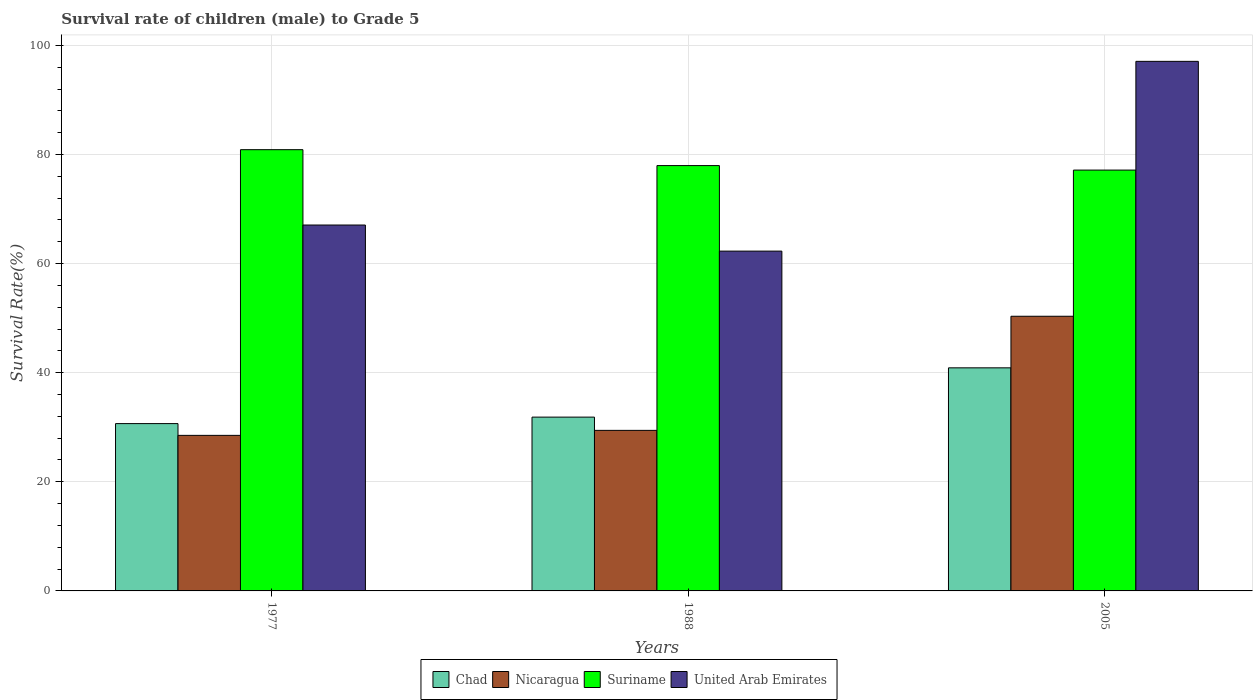How many groups of bars are there?
Provide a succinct answer. 3. Are the number of bars on each tick of the X-axis equal?
Provide a short and direct response. Yes. What is the label of the 2nd group of bars from the left?
Keep it short and to the point. 1988. What is the survival rate of male children to grade 5 in Suriname in 2005?
Make the answer very short. 77.14. Across all years, what is the maximum survival rate of male children to grade 5 in Nicaragua?
Offer a very short reply. 50.35. Across all years, what is the minimum survival rate of male children to grade 5 in United Arab Emirates?
Offer a very short reply. 62.29. In which year was the survival rate of male children to grade 5 in Chad minimum?
Keep it short and to the point. 1977. What is the total survival rate of male children to grade 5 in Suriname in the graph?
Your response must be concise. 235.98. What is the difference between the survival rate of male children to grade 5 in Nicaragua in 1977 and that in 1988?
Your answer should be very brief. -0.92. What is the difference between the survival rate of male children to grade 5 in United Arab Emirates in 1988 and the survival rate of male children to grade 5 in Suriname in 2005?
Offer a very short reply. -14.85. What is the average survival rate of male children to grade 5 in United Arab Emirates per year?
Make the answer very short. 75.47. In the year 2005, what is the difference between the survival rate of male children to grade 5 in Suriname and survival rate of male children to grade 5 in Chad?
Offer a terse response. 36.25. What is the ratio of the survival rate of male children to grade 5 in Nicaragua in 1977 to that in 1988?
Keep it short and to the point. 0.97. Is the survival rate of male children to grade 5 in United Arab Emirates in 1988 less than that in 2005?
Provide a succinct answer. Yes. What is the difference between the highest and the second highest survival rate of male children to grade 5 in United Arab Emirates?
Your answer should be very brief. 30. What is the difference between the highest and the lowest survival rate of male children to grade 5 in Nicaragua?
Offer a terse response. 21.83. What does the 3rd bar from the left in 1977 represents?
Your answer should be compact. Suriname. What does the 4th bar from the right in 1988 represents?
Provide a succinct answer. Chad. How many bars are there?
Your response must be concise. 12. Are all the bars in the graph horizontal?
Make the answer very short. No. How many years are there in the graph?
Your response must be concise. 3. What is the difference between two consecutive major ticks on the Y-axis?
Make the answer very short. 20. Are the values on the major ticks of Y-axis written in scientific E-notation?
Keep it short and to the point. No. Does the graph contain any zero values?
Your answer should be very brief. No. Does the graph contain grids?
Give a very brief answer. Yes. Where does the legend appear in the graph?
Your response must be concise. Bottom center. How many legend labels are there?
Your response must be concise. 4. What is the title of the graph?
Your response must be concise. Survival rate of children (male) to Grade 5. What is the label or title of the X-axis?
Give a very brief answer. Years. What is the label or title of the Y-axis?
Ensure brevity in your answer.  Survival Rate(%). What is the Survival Rate(%) in Chad in 1977?
Make the answer very short. 30.67. What is the Survival Rate(%) in Nicaragua in 1977?
Ensure brevity in your answer.  28.51. What is the Survival Rate(%) in Suriname in 1977?
Offer a very short reply. 80.88. What is the Survival Rate(%) of United Arab Emirates in 1977?
Your answer should be compact. 67.07. What is the Survival Rate(%) in Chad in 1988?
Your response must be concise. 31.86. What is the Survival Rate(%) in Nicaragua in 1988?
Keep it short and to the point. 29.43. What is the Survival Rate(%) in Suriname in 1988?
Make the answer very short. 77.97. What is the Survival Rate(%) in United Arab Emirates in 1988?
Offer a very short reply. 62.29. What is the Survival Rate(%) of Chad in 2005?
Your answer should be compact. 40.89. What is the Survival Rate(%) in Nicaragua in 2005?
Your answer should be very brief. 50.35. What is the Survival Rate(%) of Suriname in 2005?
Offer a very short reply. 77.14. What is the Survival Rate(%) of United Arab Emirates in 2005?
Provide a succinct answer. 97.07. Across all years, what is the maximum Survival Rate(%) of Chad?
Keep it short and to the point. 40.89. Across all years, what is the maximum Survival Rate(%) in Nicaragua?
Your answer should be very brief. 50.35. Across all years, what is the maximum Survival Rate(%) of Suriname?
Your response must be concise. 80.88. Across all years, what is the maximum Survival Rate(%) in United Arab Emirates?
Ensure brevity in your answer.  97.07. Across all years, what is the minimum Survival Rate(%) in Chad?
Give a very brief answer. 30.67. Across all years, what is the minimum Survival Rate(%) in Nicaragua?
Keep it short and to the point. 28.51. Across all years, what is the minimum Survival Rate(%) in Suriname?
Offer a terse response. 77.14. Across all years, what is the minimum Survival Rate(%) of United Arab Emirates?
Your answer should be compact. 62.29. What is the total Survival Rate(%) of Chad in the graph?
Make the answer very short. 103.42. What is the total Survival Rate(%) of Nicaragua in the graph?
Offer a terse response. 108.29. What is the total Survival Rate(%) in Suriname in the graph?
Make the answer very short. 235.98. What is the total Survival Rate(%) of United Arab Emirates in the graph?
Make the answer very short. 226.42. What is the difference between the Survival Rate(%) in Chad in 1977 and that in 1988?
Offer a very short reply. -1.19. What is the difference between the Survival Rate(%) in Nicaragua in 1977 and that in 1988?
Provide a succinct answer. -0.92. What is the difference between the Survival Rate(%) in Suriname in 1977 and that in 1988?
Your answer should be compact. 2.92. What is the difference between the Survival Rate(%) in United Arab Emirates in 1977 and that in 1988?
Ensure brevity in your answer.  4.78. What is the difference between the Survival Rate(%) in Chad in 1977 and that in 2005?
Provide a short and direct response. -10.22. What is the difference between the Survival Rate(%) of Nicaragua in 1977 and that in 2005?
Your response must be concise. -21.83. What is the difference between the Survival Rate(%) in Suriname in 1977 and that in 2005?
Make the answer very short. 3.74. What is the difference between the Survival Rate(%) of United Arab Emirates in 1977 and that in 2005?
Make the answer very short. -30. What is the difference between the Survival Rate(%) in Chad in 1988 and that in 2005?
Keep it short and to the point. -9.03. What is the difference between the Survival Rate(%) of Nicaragua in 1988 and that in 2005?
Your answer should be compact. -20.92. What is the difference between the Survival Rate(%) in Suriname in 1988 and that in 2005?
Offer a terse response. 0.83. What is the difference between the Survival Rate(%) in United Arab Emirates in 1988 and that in 2005?
Make the answer very short. -34.78. What is the difference between the Survival Rate(%) of Chad in 1977 and the Survival Rate(%) of Nicaragua in 1988?
Your answer should be very brief. 1.24. What is the difference between the Survival Rate(%) of Chad in 1977 and the Survival Rate(%) of Suriname in 1988?
Ensure brevity in your answer.  -47.29. What is the difference between the Survival Rate(%) of Chad in 1977 and the Survival Rate(%) of United Arab Emirates in 1988?
Make the answer very short. -31.62. What is the difference between the Survival Rate(%) of Nicaragua in 1977 and the Survival Rate(%) of Suriname in 1988?
Provide a succinct answer. -49.45. What is the difference between the Survival Rate(%) of Nicaragua in 1977 and the Survival Rate(%) of United Arab Emirates in 1988?
Offer a very short reply. -33.77. What is the difference between the Survival Rate(%) in Suriname in 1977 and the Survival Rate(%) in United Arab Emirates in 1988?
Ensure brevity in your answer.  18.59. What is the difference between the Survival Rate(%) in Chad in 1977 and the Survival Rate(%) in Nicaragua in 2005?
Provide a succinct answer. -19.68. What is the difference between the Survival Rate(%) of Chad in 1977 and the Survival Rate(%) of Suriname in 2005?
Make the answer very short. -46.47. What is the difference between the Survival Rate(%) of Chad in 1977 and the Survival Rate(%) of United Arab Emirates in 2005?
Your answer should be very brief. -66.4. What is the difference between the Survival Rate(%) of Nicaragua in 1977 and the Survival Rate(%) of Suriname in 2005?
Give a very brief answer. -48.63. What is the difference between the Survival Rate(%) of Nicaragua in 1977 and the Survival Rate(%) of United Arab Emirates in 2005?
Offer a very short reply. -68.56. What is the difference between the Survival Rate(%) in Suriname in 1977 and the Survival Rate(%) in United Arab Emirates in 2005?
Your response must be concise. -16.19. What is the difference between the Survival Rate(%) in Chad in 1988 and the Survival Rate(%) in Nicaragua in 2005?
Provide a succinct answer. -18.49. What is the difference between the Survival Rate(%) in Chad in 1988 and the Survival Rate(%) in Suriname in 2005?
Offer a terse response. -45.28. What is the difference between the Survival Rate(%) of Chad in 1988 and the Survival Rate(%) of United Arab Emirates in 2005?
Provide a succinct answer. -65.21. What is the difference between the Survival Rate(%) of Nicaragua in 1988 and the Survival Rate(%) of Suriname in 2005?
Ensure brevity in your answer.  -47.71. What is the difference between the Survival Rate(%) in Nicaragua in 1988 and the Survival Rate(%) in United Arab Emirates in 2005?
Provide a short and direct response. -67.64. What is the difference between the Survival Rate(%) of Suriname in 1988 and the Survival Rate(%) of United Arab Emirates in 2005?
Your answer should be compact. -19.1. What is the average Survival Rate(%) of Chad per year?
Your answer should be compact. 34.47. What is the average Survival Rate(%) in Nicaragua per year?
Your answer should be compact. 36.1. What is the average Survival Rate(%) in Suriname per year?
Your response must be concise. 78.66. What is the average Survival Rate(%) of United Arab Emirates per year?
Offer a very short reply. 75.47. In the year 1977, what is the difference between the Survival Rate(%) of Chad and Survival Rate(%) of Nicaragua?
Offer a terse response. 2.16. In the year 1977, what is the difference between the Survival Rate(%) in Chad and Survival Rate(%) in Suriname?
Keep it short and to the point. -50.21. In the year 1977, what is the difference between the Survival Rate(%) of Chad and Survival Rate(%) of United Arab Emirates?
Offer a very short reply. -36.4. In the year 1977, what is the difference between the Survival Rate(%) in Nicaragua and Survival Rate(%) in Suriname?
Your answer should be very brief. -52.37. In the year 1977, what is the difference between the Survival Rate(%) in Nicaragua and Survival Rate(%) in United Arab Emirates?
Keep it short and to the point. -38.56. In the year 1977, what is the difference between the Survival Rate(%) in Suriname and Survival Rate(%) in United Arab Emirates?
Provide a succinct answer. 13.81. In the year 1988, what is the difference between the Survival Rate(%) of Chad and Survival Rate(%) of Nicaragua?
Keep it short and to the point. 2.43. In the year 1988, what is the difference between the Survival Rate(%) of Chad and Survival Rate(%) of Suriname?
Make the answer very short. -46.11. In the year 1988, what is the difference between the Survival Rate(%) of Chad and Survival Rate(%) of United Arab Emirates?
Your answer should be very brief. -30.43. In the year 1988, what is the difference between the Survival Rate(%) of Nicaragua and Survival Rate(%) of Suriname?
Your answer should be very brief. -48.54. In the year 1988, what is the difference between the Survival Rate(%) in Nicaragua and Survival Rate(%) in United Arab Emirates?
Keep it short and to the point. -32.86. In the year 1988, what is the difference between the Survival Rate(%) of Suriname and Survival Rate(%) of United Arab Emirates?
Your answer should be compact. 15.68. In the year 2005, what is the difference between the Survival Rate(%) in Chad and Survival Rate(%) in Nicaragua?
Offer a very short reply. -9.46. In the year 2005, what is the difference between the Survival Rate(%) of Chad and Survival Rate(%) of Suriname?
Keep it short and to the point. -36.25. In the year 2005, what is the difference between the Survival Rate(%) in Chad and Survival Rate(%) in United Arab Emirates?
Your answer should be compact. -56.18. In the year 2005, what is the difference between the Survival Rate(%) of Nicaragua and Survival Rate(%) of Suriname?
Ensure brevity in your answer.  -26.79. In the year 2005, what is the difference between the Survival Rate(%) of Nicaragua and Survival Rate(%) of United Arab Emirates?
Offer a very short reply. -46.72. In the year 2005, what is the difference between the Survival Rate(%) in Suriname and Survival Rate(%) in United Arab Emirates?
Give a very brief answer. -19.93. What is the ratio of the Survival Rate(%) of Chad in 1977 to that in 1988?
Your answer should be very brief. 0.96. What is the ratio of the Survival Rate(%) in Nicaragua in 1977 to that in 1988?
Your answer should be very brief. 0.97. What is the ratio of the Survival Rate(%) in Suriname in 1977 to that in 1988?
Keep it short and to the point. 1.04. What is the ratio of the Survival Rate(%) of United Arab Emirates in 1977 to that in 1988?
Your answer should be very brief. 1.08. What is the ratio of the Survival Rate(%) in Chad in 1977 to that in 2005?
Ensure brevity in your answer.  0.75. What is the ratio of the Survival Rate(%) in Nicaragua in 1977 to that in 2005?
Make the answer very short. 0.57. What is the ratio of the Survival Rate(%) of Suriname in 1977 to that in 2005?
Provide a succinct answer. 1.05. What is the ratio of the Survival Rate(%) of United Arab Emirates in 1977 to that in 2005?
Your answer should be compact. 0.69. What is the ratio of the Survival Rate(%) in Chad in 1988 to that in 2005?
Ensure brevity in your answer.  0.78. What is the ratio of the Survival Rate(%) in Nicaragua in 1988 to that in 2005?
Offer a very short reply. 0.58. What is the ratio of the Survival Rate(%) in Suriname in 1988 to that in 2005?
Provide a short and direct response. 1.01. What is the ratio of the Survival Rate(%) in United Arab Emirates in 1988 to that in 2005?
Offer a very short reply. 0.64. What is the difference between the highest and the second highest Survival Rate(%) of Chad?
Offer a very short reply. 9.03. What is the difference between the highest and the second highest Survival Rate(%) of Nicaragua?
Provide a short and direct response. 20.92. What is the difference between the highest and the second highest Survival Rate(%) in Suriname?
Provide a short and direct response. 2.92. What is the difference between the highest and the second highest Survival Rate(%) of United Arab Emirates?
Your response must be concise. 30. What is the difference between the highest and the lowest Survival Rate(%) in Chad?
Make the answer very short. 10.22. What is the difference between the highest and the lowest Survival Rate(%) of Nicaragua?
Your response must be concise. 21.83. What is the difference between the highest and the lowest Survival Rate(%) in Suriname?
Your answer should be compact. 3.74. What is the difference between the highest and the lowest Survival Rate(%) of United Arab Emirates?
Your answer should be very brief. 34.78. 